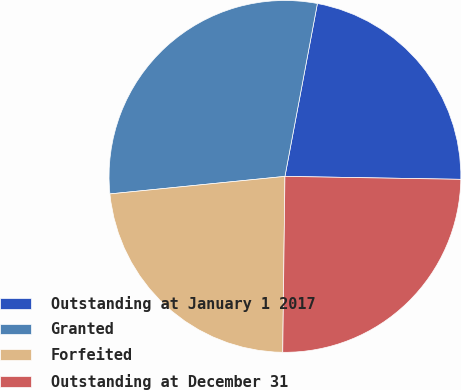Convert chart to OTSL. <chart><loc_0><loc_0><loc_500><loc_500><pie_chart><fcel>Outstanding at January 1 2017<fcel>Granted<fcel>Forfeited<fcel>Outstanding at December 31<nl><fcel>22.31%<fcel>29.54%<fcel>23.21%<fcel>24.93%<nl></chart> 